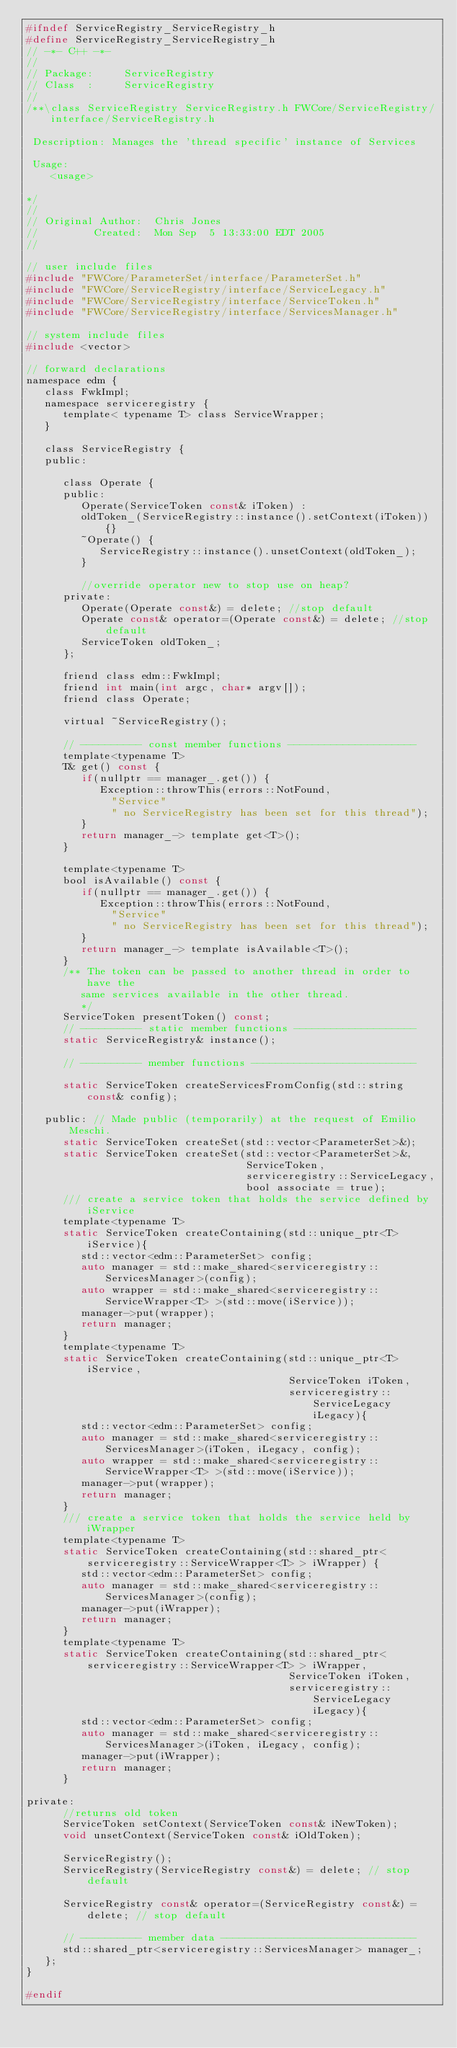<code> <loc_0><loc_0><loc_500><loc_500><_C_>#ifndef ServiceRegistry_ServiceRegistry_h
#define ServiceRegistry_ServiceRegistry_h
// -*- C++ -*-
//
// Package:     ServiceRegistry
// Class  :     ServiceRegistry
//
/**\class ServiceRegistry ServiceRegistry.h FWCore/ServiceRegistry/interface/ServiceRegistry.h

 Description: Manages the 'thread specific' instance of Services

 Usage:
    <usage>

*/
//
// Original Author:  Chris Jones
//         Created:  Mon Sep  5 13:33:00 EDT 2005
//

// user include files
#include "FWCore/ParameterSet/interface/ParameterSet.h"
#include "FWCore/ServiceRegistry/interface/ServiceLegacy.h"
#include "FWCore/ServiceRegistry/interface/ServiceToken.h"
#include "FWCore/ServiceRegistry/interface/ServicesManager.h"

// system include files
#include <vector>

// forward declarations
namespace edm {
   class FwkImpl;
   namespace serviceregistry {
      template< typename T> class ServiceWrapper;
   }

   class ServiceRegistry {
   public:

      class Operate {
      public:
         Operate(ServiceToken const& iToken) :
         oldToken_(ServiceRegistry::instance().setContext(iToken)) {}
         ~Operate() {
            ServiceRegistry::instance().unsetContext(oldToken_);
         }

         //override operator new to stop use on heap?
      private:
         Operate(Operate const&) = delete; //stop default
         Operate const& operator=(Operate const&) = delete; //stop default
         ServiceToken oldToken_;
      };

      friend class edm::FwkImpl;
      friend int main(int argc, char* argv[]);
      friend class Operate;

      virtual ~ServiceRegistry();

      // ---------- const member functions ---------------------
      template<typename T>
      T& get() const {
         if(nullptr == manager_.get()) {
            Exception::throwThis(errors::NotFound,
              "Service"
              " no ServiceRegistry has been set for this thread");
         }
         return manager_-> template get<T>();
      }

      template<typename T>
      bool isAvailable() const {
         if(nullptr == manager_.get()) {
            Exception::throwThis(errors::NotFound,
              "Service"
              " no ServiceRegistry has been set for this thread");
         }
         return manager_-> template isAvailable<T>();
      }
      /** The token can be passed to another thread in order to have the
         same services available in the other thread.
         */
      ServiceToken presentToken() const;
      // ---------- static member functions --------------------
      static ServiceRegistry& instance();

      // ---------- member functions ---------------------------

      static ServiceToken createServicesFromConfig(std::string const& config);

   public: // Made public (temporarily) at the request of Emilio Meschi.
      static ServiceToken createSet(std::vector<ParameterSet>&);
      static ServiceToken createSet(std::vector<ParameterSet>&,
                                    ServiceToken,
                                    serviceregistry::ServiceLegacy,
                                    bool associate = true);
      /// create a service token that holds the service defined by iService
      template<typename T>
      static ServiceToken createContaining(std::unique_ptr<T> iService){
         std::vector<edm::ParameterSet> config;
         auto manager = std::make_shared<serviceregistry::ServicesManager>(config);
         auto wrapper = std::make_shared<serviceregistry::ServiceWrapper<T> >(std::move(iService));
         manager->put(wrapper);
         return manager;
      }
      template<typename T>
      static ServiceToken createContaining(std::unique_ptr<T> iService,
                                           ServiceToken iToken,
                                           serviceregistry::ServiceLegacy iLegacy){
         std::vector<edm::ParameterSet> config;
         auto manager = std::make_shared<serviceregistry::ServicesManager>(iToken, iLegacy, config);
         auto wrapper = std::make_shared<serviceregistry::ServiceWrapper<T> >(std::move(iService));
         manager->put(wrapper);
         return manager;
      }
      /// create a service token that holds the service held by iWrapper
      template<typename T>
      static ServiceToken createContaining(std::shared_ptr<serviceregistry::ServiceWrapper<T> > iWrapper) {
         std::vector<edm::ParameterSet> config;
         auto manager = std::make_shared<serviceregistry::ServicesManager>(config);
         manager->put(iWrapper);
         return manager;
      }
      template<typename T>
      static ServiceToken createContaining(std::shared_ptr<serviceregistry::ServiceWrapper<T> > iWrapper,
                                           ServiceToken iToken,
                                           serviceregistry::ServiceLegacy iLegacy){
         std::vector<edm::ParameterSet> config;
         auto manager = std::make_shared<serviceregistry::ServicesManager>(iToken, iLegacy, config);
         manager->put(iWrapper);
         return manager;
      }

private:
      //returns old token
      ServiceToken setContext(ServiceToken const& iNewToken);
      void unsetContext(ServiceToken const& iOldToken);

      ServiceRegistry();
      ServiceRegistry(ServiceRegistry const&) = delete; // stop default

      ServiceRegistry const& operator=(ServiceRegistry const&) = delete; // stop default

      // ---------- member data --------------------------------
      std::shared_ptr<serviceregistry::ServicesManager> manager_;
   };
}

#endif
</code> 